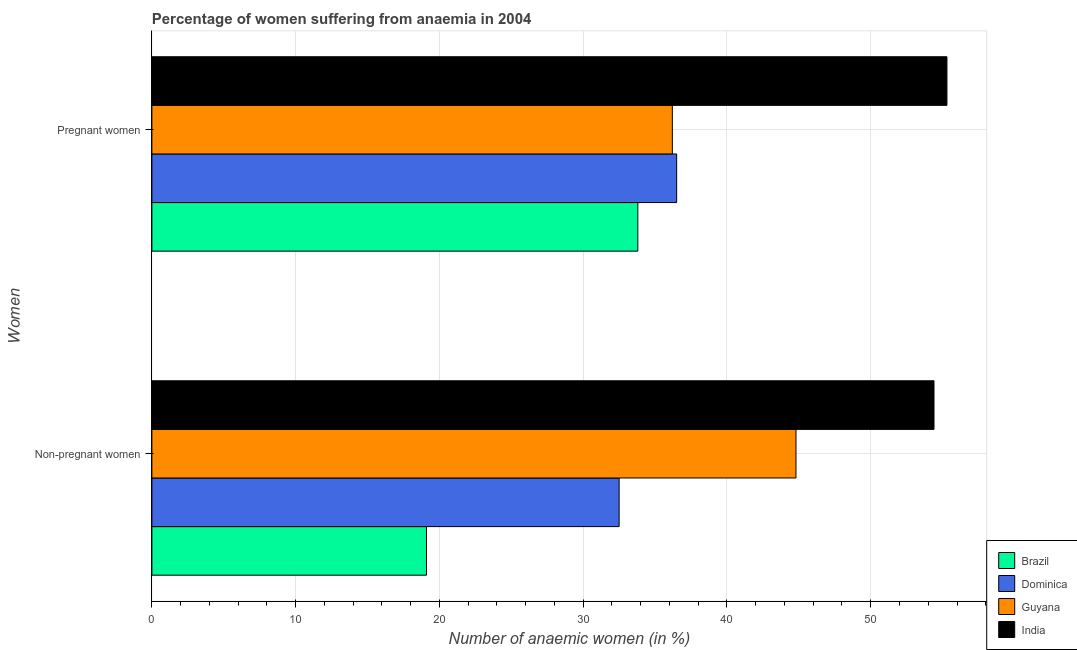Are the number of bars per tick equal to the number of legend labels?
Provide a short and direct response. Yes. Are the number of bars on each tick of the Y-axis equal?
Your answer should be compact. Yes. How many bars are there on the 1st tick from the top?
Provide a short and direct response. 4. How many bars are there on the 1st tick from the bottom?
Offer a terse response. 4. What is the label of the 1st group of bars from the top?
Offer a very short reply. Pregnant women. What is the percentage of pregnant anaemic women in India?
Make the answer very short. 55.3. Across all countries, what is the maximum percentage of pregnant anaemic women?
Provide a succinct answer. 55.3. In which country was the percentage of pregnant anaemic women maximum?
Make the answer very short. India. What is the total percentage of pregnant anaemic women in the graph?
Keep it short and to the point. 161.8. What is the difference between the percentage of non-pregnant anaemic women in India and that in Guyana?
Offer a terse response. 9.6. What is the difference between the percentage of non-pregnant anaemic women in Brazil and the percentage of pregnant anaemic women in India?
Offer a terse response. -36.2. What is the average percentage of non-pregnant anaemic women per country?
Keep it short and to the point. 37.7. In how many countries, is the percentage of pregnant anaemic women greater than 42 %?
Your answer should be compact. 1. What is the ratio of the percentage of pregnant anaemic women in Dominica to that in Guyana?
Keep it short and to the point. 1.01. In how many countries, is the percentage of non-pregnant anaemic women greater than the average percentage of non-pregnant anaemic women taken over all countries?
Ensure brevity in your answer.  2. What does the 2nd bar from the top in Non-pregnant women represents?
Make the answer very short. Guyana. What does the 1st bar from the bottom in Non-pregnant women represents?
Offer a terse response. Brazil. Are all the bars in the graph horizontal?
Give a very brief answer. Yes. How many countries are there in the graph?
Provide a short and direct response. 4. Are the values on the major ticks of X-axis written in scientific E-notation?
Offer a terse response. No. Where does the legend appear in the graph?
Offer a very short reply. Bottom right. How many legend labels are there?
Make the answer very short. 4. What is the title of the graph?
Your answer should be compact. Percentage of women suffering from anaemia in 2004. Does "Guyana" appear as one of the legend labels in the graph?
Provide a succinct answer. Yes. What is the label or title of the X-axis?
Provide a succinct answer. Number of anaemic women (in %). What is the label or title of the Y-axis?
Keep it short and to the point. Women. What is the Number of anaemic women (in %) in Dominica in Non-pregnant women?
Your response must be concise. 32.5. What is the Number of anaemic women (in %) of Guyana in Non-pregnant women?
Make the answer very short. 44.8. What is the Number of anaemic women (in %) of India in Non-pregnant women?
Provide a succinct answer. 54.4. What is the Number of anaemic women (in %) in Brazil in Pregnant women?
Keep it short and to the point. 33.8. What is the Number of anaemic women (in %) in Dominica in Pregnant women?
Your answer should be compact. 36.5. What is the Number of anaemic women (in %) in Guyana in Pregnant women?
Ensure brevity in your answer.  36.2. What is the Number of anaemic women (in %) in India in Pregnant women?
Your answer should be very brief. 55.3. Across all Women, what is the maximum Number of anaemic women (in %) in Brazil?
Make the answer very short. 33.8. Across all Women, what is the maximum Number of anaemic women (in %) in Dominica?
Offer a terse response. 36.5. Across all Women, what is the maximum Number of anaemic women (in %) in Guyana?
Ensure brevity in your answer.  44.8. Across all Women, what is the maximum Number of anaemic women (in %) in India?
Your answer should be very brief. 55.3. Across all Women, what is the minimum Number of anaemic women (in %) of Brazil?
Give a very brief answer. 19.1. Across all Women, what is the minimum Number of anaemic women (in %) in Dominica?
Offer a very short reply. 32.5. Across all Women, what is the minimum Number of anaemic women (in %) of Guyana?
Make the answer very short. 36.2. Across all Women, what is the minimum Number of anaemic women (in %) in India?
Offer a terse response. 54.4. What is the total Number of anaemic women (in %) in Brazil in the graph?
Make the answer very short. 52.9. What is the total Number of anaemic women (in %) in Dominica in the graph?
Offer a very short reply. 69. What is the total Number of anaemic women (in %) of Guyana in the graph?
Offer a terse response. 81. What is the total Number of anaemic women (in %) in India in the graph?
Your response must be concise. 109.7. What is the difference between the Number of anaemic women (in %) in Brazil in Non-pregnant women and that in Pregnant women?
Your answer should be very brief. -14.7. What is the difference between the Number of anaemic women (in %) of Dominica in Non-pregnant women and that in Pregnant women?
Give a very brief answer. -4. What is the difference between the Number of anaemic women (in %) in Guyana in Non-pregnant women and that in Pregnant women?
Your response must be concise. 8.6. What is the difference between the Number of anaemic women (in %) in India in Non-pregnant women and that in Pregnant women?
Your answer should be very brief. -0.9. What is the difference between the Number of anaemic women (in %) of Brazil in Non-pregnant women and the Number of anaemic women (in %) of Dominica in Pregnant women?
Make the answer very short. -17.4. What is the difference between the Number of anaemic women (in %) of Brazil in Non-pregnant women and the Number of anaemic women (in %) of Guyana in Pregnant women?
Your answer should be compact. -17.1. What is the difference between the Number of anaemic women (in %) of Brazil in Non-pregnant women and the Number of anaemic women (in %) of India in Pregnant women?
Provide a succinct answer. -36.2. What is the difference between the Number of anaemic women (in %) in Dominica in Non-pregnant women and the Number of anaemic women (in %) in Guyana in Pregnant women?
Ensure brevity in your answer.  -3.7. What is the difference between the Number of anaemic women (in %) in Dominica in Non-pregnant women and the Number of anaemic women (in %) in India in Pregnant women?
Offer a terse response. -22.8. What is the average Number of anaemic women (in %) of Brazil per Women?
Offer a terse response. 26.45. What is the average Number of anaemic women (in %) in Dominica per Women?
Offer a very short reply. 34.5. What is the average Number of anaemic women (in %) of Guyana per Women?
Provide a short and direct response. 40.5. What is the average Number of anaemic women (in %) in India per Women?
Your answer should be very brief. 54.85. What is the difference between the Number of anaemic women (in %) of Brazil and Number of anaemic women (in %) of Guyana in Non-pregnant women?
Offer a very short reply. -25.7. What is the difference between the Number of anaemic women (in %) in Brazil and Number of anaemic women (in %) in India in Non-pregnant women?
Your response must be concise. -35.3. What is the difference between the Number of anaemic women (in %) of Dominica and Number of anaemic women (in %) of Guyana in Non-pregnant women?
Offer a terse response. -12.3. What is the difference between the Number of anaemic women (in %) of Dominica and Number of anaemic women (in %) of India in Non-pregnant women?
Ensure brevity in your answer.  -21.9. What is the difference between the Number of anaemic women (in %) of Guyana and Number of anaemic women (in %) of India in Non-pregnant women?
Keep it short and to the point. -9.6. What is the difference between the Number of anaemic women (in %) of Brazil and Number of anaemic women (in %) of Dominica in Pregnant women?
Your answer should be compact. -2.7. What is the difference between the Number of anaemic women (in %) of Brazil and Number of anaemic women (in %) of Guyana in Pregnant women?
Keep it short and to the point. -2.4. What is the difference between the Number of anaemic women (in %) of Brazil and Number of anaemic women (in %) of India in Pregnant women?
Your response must be concise. -21.5. What is the difference between the Number of anaemic women (in %) of Dominica and Number of anaemic women (in %) of Guyana in Pregnant women?
Provide a short and direct response. 0.3. What is the difference between the Number of anaemic women (in %) in Dominica and Number of anaemic women (in %) in India in Pregnant women?
Offer a terse response. -18.8. What is the difference between the Number of anaemic women (in %) of Guyana and Number of anaemic women (in %) of India in Pregnant women?
Ensure brevity in your answer.  -19.1. What is the ratio of the Number of anaemic women (in %) of Brazil in Non-pregnant women to that in Pregnant women?
Give a very brief answer. 0.57. What is the ratio of the Number of anaemic women (in %) in Dominica in Non-pregnant women to that in Pregnant women?
Offer a very short reply. 0.89. What is the ratio of the Number of anaemic women (in %) of Guyana in Non-pregnant women to that in Pregnant women?
Provide a succinct answer. 1.24. What is the ratio of the Number of anaemic women (in %) of India in Non-pregnant women to that in Pregnant women?
Provide a short and direct response. 0.98. What is the difference between the highest and the second highest Number of anaemic women (in %) of Brazil?
Provide a succinct answer. 14.7. What is the difference between the highest and the second highest Number of anaemic women (in %) of Guyana?
Offer a terse response. 8.6. What is the difference between the highest and the second highest Number of anaemic women (in %) of India?
Ensure brevity in your answer.  0.9. What is the difference between the highest and the lowest Number of anaemic women (in %) in Brazil?
Provide a succinct answer. 14.7. What is the difference between the highest and the lowest Number of anaemic women (in %) of Dominica?
Give a very brief answer. 4. What is the difference between the highest and the lowest Number of anaemic women (in %) in India?
Your answer should be compact. 0.9. 